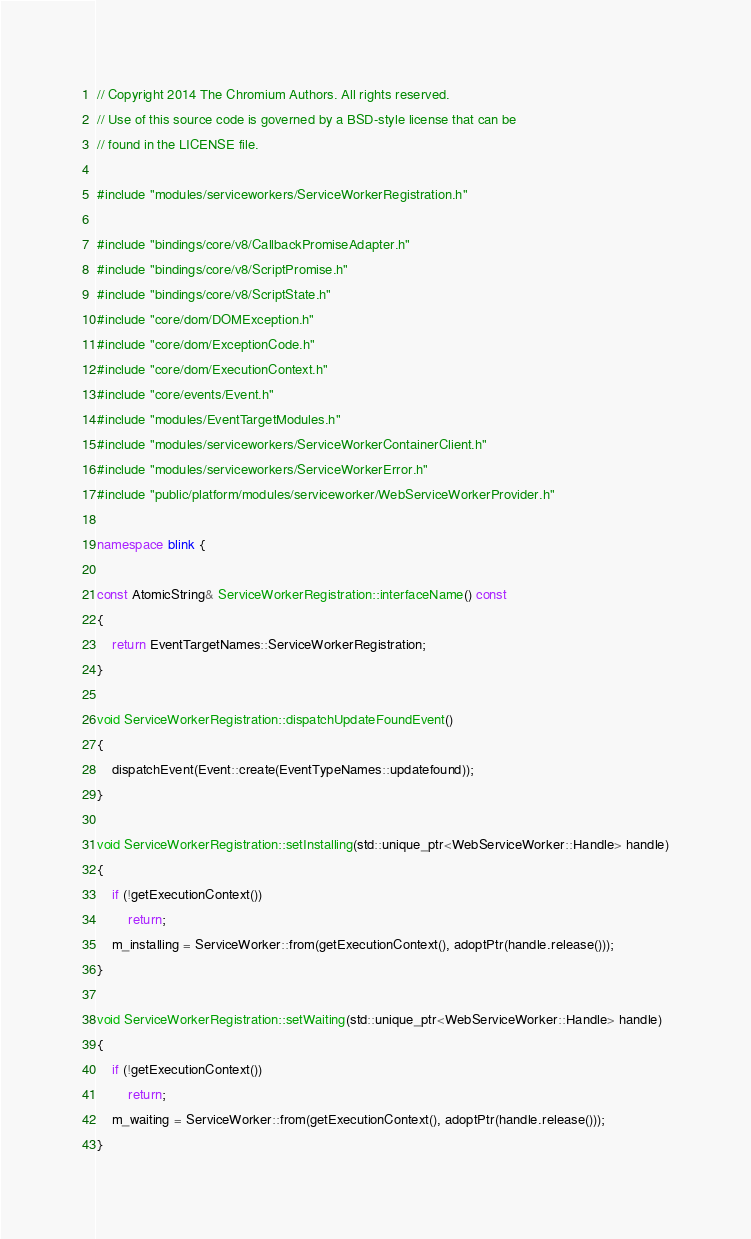Convert code to text. <code><loc_0><loc_0><loc_500><loc_500><_C++_>// Copyright 2014 The Chromium Authors. All rights reserved.
// Use of this source code is governed by a BSD-style license that can be
// found in the LICENSE file.

#include "modules/serviceworkers/ServiceWorkerRegistration.h"

#include "bindings/core/v8/CallbackPromiseAdapter.h"
#include "bindings/core/v8/ScriptPromise.h"
#include "bindings/core/v8/ScriptState.h"
#include "core/dom/DOMException.h"
#include "core/dom/ExceptionCode.h"
#include "core/dom/ExecutionContext.h"
#include "core/events/Event.h"
#include "modules/EventTargetModules.h"
#include "modules/serviceworkers/ServiceWorkerContainerClient.h"
#include "modules/serviceworkers/ServiceWorkerError.h"
#include "public/platform/modules/serviceworker/WebServiceWorkerProvider.h"

namespace blink {

const AtomicString& ServiceWorkerRegistration::interfaceName() const
{
    return EventTargetNames::ServiceWorkerRegistration;
}

void ServiceWorkerRegistration::dispatchUpdateFoundEvent()
{
    dispatchEvent(Event::create(EventTypeNames::updatefound));
}

void ServiceWorkerRegistration::setInstalling(std::unique_ptr<WebServiceWorker::Handle> handle)
{
    if (!getExecutionContext())
        return;
    m_installing = ServiceWorker::from(getExecutionContext(), adoptPtr(handle.release()));
}

void ServiceWorkerRegistration::setWaiting(std::unique_ptr<WebServiceWorker::Handle> handle)
{
    if (!getExecutionContext())
        return;
    m_waiting = ServiceWorker::from(getExecutionContext(), adoptPtr(handle.release()));
}
</code> 